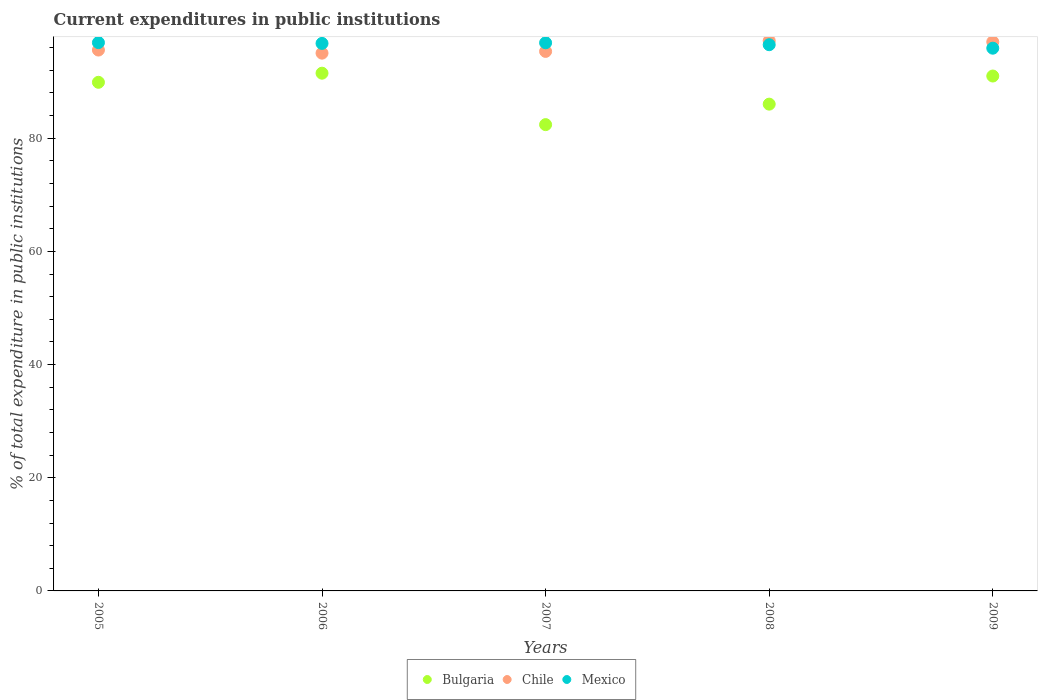What is the current expenditures in public institutions in Chile in 2008?
Provide a succinct answer. 97.23. Across all years, what is the maximum current expenditures in public institutions in Bulgaria?
Ensure brevity in your answer.  91.5. Across all years, what is the minimum current expenditures in public institutions in Bulgaria?
Your response must be concise. 82.41. In which year was the current expenditures in public institutions in Chile minimum?
Make the answer very short. 2006. What is the total current expenditures in public institutions in Chile in the graph?
Provide a succinct answer. 480.24. What is the difference between the current expenditures in public institutions in Mexico in 2007 and that in 2008?
Ensure brevity in your answer.  0.34. What is the difference between the current expenditures in public institutions in Mexico in 2005 and the current expenditures in public institutions in Chile in 2007?
Offer a terse response. 1.55. What is the average current expenditures in public institutions in Bulgaria per year?
Make the answer very short. 88.16. In the year 2008, what is the difference between the current expenditures in public institutions in Chile and current expenditures in public institutions in Mexico?
Your answer should be very brief. 0.7. In how many years, is the current expenditures in public institutions in Bulgaria greater than 20 %?
Make the answer very short. 5. What is the ratio of the current expenditures in public institutions in Mexico in 2007 to that in 2008?
Provide a succinct answer. 1. What is the difference between the highest and the second highest current expenditures in public institutions in Bulgaria?
Offer a very short reply. 0.5. What is the difference between the highest and the lowest current expenditures in public institutions in Mexico?
Provide a short and direct response. 0.99. In how many years, is the current expenditures in public institutions in Bulgaria greater than the average current expenditures in public institutions in Bulgaria taken over all years?
Give a very brief answer. 3. Is it the case that in every year, the sum of the current expenditures in public institutions in Chile and current expenditures in public institutions in Bulgaria  is greater than the current expenditures in public institutions in Mexico?
Give a very brief answer. Yes. Is the current expenditures in public institutions in Bulgaria strictly less than the current expenditures in public institutions in Mexico over the years?
Provide a short and direct response. Yes. What is the difference between two consecutive major ticks on the Y-axis?
Make the answer very short. 20. Does the graph contain any zero values?
Ensure brevity in your answer.  No. Where does the legend appear in the graph?
Your answer should be compact. Bottom center. How many legend labels are there?
Make the answer very short. 3. What is the title of the graph?
Make the answer very short. Current expenditures in public institutions. What is the label or title of the X-axis?
Give a very brief answer. Years. What is the label or title of the Y-axis?
Offer a very short reply. % of total expenditure in public institutions. What is the % of total expenditure in public institutions of Bulgaria in 2005?
Provide a short and direct response. 89.89. What is the % of total expenditure in public institutions in Chile in 2005?
Your response must be concise. 95.59. What is the % of total expenditure in public institutions in Mexico in 2005?
Make the answer very short. 96.9. What is the % of total expenditure in public institutions in Bulgaria in 2006?
Make the answer very short. 91.5. What is the % of total expenditure in public institutions in Chile in 2006?
Ensure brevity in your answer.  95.04. What is the % of total expenditure in public institutions of Mexico in 2006?
Provide a succinct answer. 96.76. What is the % of total expenditure in public institutions of Bulgaria in 2007?
Your response must be concise. 82.41. What is the % of total expenditure in public institutions of Chile in 2007?
Give a very brief answer. 95.35. What is the % of total expenditure in public institutions of Mexico in 2007?
Your response must be concise. 96.87. What is the % of total expenditure in public institutions of Bulgaria in 2008?
Offer a very short reply. 86.03. What is the % of total expenditure in public institutions of Chile in 2008?
Make the answer very short. 97.23. What is the % of total expenditure in public institutions of Mexico in 2008?
Offer a very short reply. 96.53. What is the % of total expenditure in public institutions of Bulgaria in 2009?
Make the answer very short. 91. What is the % of total expenditure in public institutions of Chile in 2009?
Offer a very short reply. 97.03. What is the % of total expenditure in public institutions in Mexico in 2009?
Make the answer very short. 95.92. Across all years, what is the maximum % of total expenditure in public institutions in Bulgaria?
Your response must be concise. 91.5. Across all years, what is the maximum % of total expenditure in public institutions of Chile?
Offer a very short reply. 97.23. Across all years, what is the maximum % of total expenditure in public institutions of Mexico?
Give a very brief answer. 96.9. Across all years, what is the minimum % of total expenditure in public institutions of Bulgaria?
Your response must be concise. 82.41. Across all years, what is the minimum % of total expenditure in public institutions in Chile?
Offer a terse response. 95.04. Across all years, what is the minimum % of total expenditure in public institutions in Mexico?
Give a very brief answer. 95.92. What is the total % of total expenditure in public institutions in Bulgaria in the graph?
Give a very brief answer. 440.82. What is the total % of total expenditure in public institutions in Chile in the graph?
Give a very brief answer. 480.24. What is the total % of total expenditure in public institutions in Mexico in the graph?
Your answer should be compact. 482.98. What is the difference between the % of total expenditure in public institutions of Bulgaria in 2005 and that in 2006?
Keep it short and to the point. -1.61. What is the difference between the % of total expenditure in public institutions of Chile in 2005 and that in 2006?
Offer a very short reply. 0.55. What is the difference between the % of total expenditure in public institutions in Mexico in 2005 and that in 2006?
Provide a short and direct response. 0.14. What is the difference between the % of total expenditure in public institutions in Bulgaria in 2005 and that in 2007?
Give a very brief answer. 7.48. What is the difference between the % of total expenditure in public institutions in Chile in 2005 and that in 2007?
Provide a short and direct response. 0.24. What is the difference between the % of total expenditure in public institutions of Mexico in 2005 and that in 2007?
Your answer should be very brief. 0.03. What is the difference between the % of total expenditure in public institutions in Bulgaria in 2005 and that in 2008?
Provide a succinct answer. 3.86. What is the difference between the % of total expenditure in public institutions in Chile in 2005 and that in 2008?
Provide a short and direct response. -1.64. What is the difference between the % of total expenditure in public institutions of Mexico in 2005 and that in 2008?
Offer a very short reply. 0.37. What is the difference between the % of total expenditure in public institutions of Bulgaria in 2005 and that in 2009?
Give a very brief answer. -1.11. What is the difference between the % of total expenditure in public institutions of Chile in 2005 and that in 2009?
Offer a very short reply. -1.44. What is the difference between the % of total expenditure in public institutions of Mexico in 2005 and that in 2009?
Make the answer very short. 0.99. What is the difference between the % of total expenditure in public institutions of Bulgaria in 2006 and that in 2007?
Offer a terse response. 9.09. What is the difference between the % of total expenditure in public institutions in Chile in 2006 and that in 2007?
Your answer should be very brief. -0.31. What is the difference between the % of total expenditure in public institutions of Mexico in 2006 and that in 2007?
Offer a very short reply. -0.11. What is the difference between the % of total expenditure in public institutions of Bulgaria in 2006 and that in 2008?
Your answer should be very brief. 5.47. What is the difference between the % of total expenditure in public institutions of Chile in 2006 and that in 2008?
Keep it short and to the point. -2.19. What is the difference between the % of total expenditure in public institutions of Mexico in 2006 and that in 2008?
Ensure brevity in your answer.  0.23. What is the difference between the % of total expenditure in public institutions of Bulgaria in 2006 and that in 2009?
Offer a terse response. 0.5. What is the difference between the % of total expenditure in public institutions of Chile in 2006 and that in 2009?
Provide a succinct answer. -1.99. What is the difference between the % of total expenditure in public institutions of Mexico in 2006 and that in 2009?
Your answer should be very brief. 0.84. What is the difference between the % of total expenditure in public institutions in Bulgaria in 2007 and that in 2008?
Offer a very short reply. -3.62. What is the difference between the % of total expenditure in public institutions in Chile in 2007 and that in 2008?
Give a very brief answer. -1.88. What is the difference between the % of total expenditure in public institutions in Mexico in 2007 and that in 2008?
Your response must be concise. 0.34. What is the difference between the % of total expenditure in public institutions of Bulgaria in 2007 and that in 2009?
Keep it short and to the point. -8.59. What is the difference between the % of total expenditure in public institutions of Chile in 2007 and that in 2009?
Keep it short and to the point. -1.68. What is the difference between the % of total expenditure in public institutions in Mexico in 2007 and that in 2009?
Your answer should be compact. 0.95. What is the difference between the % of total expenditure in public institutions in Bulgaria in 2008 and that in 2009?
Provide a succinct answer. -4.97. What is the difference between the % of total expenditure in public institutions in Chile in 2008 and that in 2009?
Your response must be concise. 0.2. What is the difference between the % of total expenditure in public institutions of Mexico in 2008 and that in 2009?
Give a very brief answer. 0.61. What is the difference between the % of total expenditure in public institutions of Bulgaria in 2005 and the % of total expenditure in public institutions of Chile in 2006?
Keep it short and to the point. -5.15. What is the difference between the % of total expenditure in public institutions of Bulgaria in 2005 and the % of total expenditure in public institutions of Mexico in 2006?
Provide a succinct answer. -6.87. What is the difference between the % of total expenditure in public institutions in Chile in 2005 and the % of total expenditure in public institutions in Mexico in 2006?
Your answer should be compact. -1.17. What is the difference between the % of total expenditure in public institutions of Bulgaria in 2005 and the % of total expenditure in public institutions of Chile in 2007?
Your response must be concise. -5.46. What is the difference between the % of total expenditure in public institutions in Bulgaria in 2005 and the % of total expenditure in public institutions in Mexico in 2007?
Provide a short and direct response. -6.98. What is the difference between the % of total expenditure in public institutions of Chile in 2005 and the % of total expenditure in public institutions of Mexico in 2007?
Give a very brief answer. -1.28. What is the difference between the % of total expenditure in public institutions of Bulgaria in 2005 and the % of total expenditure in public institutions of Chile in 2008?
Ensure brevity in your answer.  -7.34. What is the difference between the % of total expenditure in public institutions in Bulgaria in 2005 and the % of total expenditure in public institutions in Mexico in 2008?
Your answer should be very brief. -6.64. What is the difference between the % of total expenditure in public institutions in Chile in 2005 and the % of total expenditure in public institutions in Mexico in 2008?
Your answer should be compact. -0.94. What is the difference between the % of total expenditure in public institutions in Bulgaria in 2005 and the % of total expenditure in public institutions in Chile in 2009?
Give a very brief answer. -7.14. What is the difference between the % of total expenditure in public institutions in Bulgaria in 2005 and the % of total expenditure in public institutions in Mexico in 2009?
Give a very brief answer. -6.03. What is the difference between the % of total expenditure in public institutions in Chile in 2005 and the % of total expenditure in public institutions in Mexico in 2009?
Provide a short and direct response. -0.33. What is the difference between the % of total expenditure in public institutions in Bulgaria in 2006 and the % of total expenditure in public institutions in Chile in 2007?
Make the answer very short. -3.85. What is the difference between the % of total expenditure in public institutions of Bulgaria in 2006 and the % of total expenditure in public institutions of Mexico in 2007?
Ensure brevity in your answer.  -5.37. What is the difference between the % of total expenditure in public institutions of Chile in 2006 and the % of total expenditure in public institutions of Mexico in 2007?
Your answer should be very brief. -1.83. What is the difference between the % of total expenditure in public institutions in Bulgaria in 2006 and the % of total expenditure in public institutions in Chile in 2008?
Offer a very short reply. -5.73. What is the difference between the % of total expenditure in public institutions of Bulgaria in 2006 and the % of total expenditure in public institutions of Mexico in 2008?
Your response must be concise. -5.03. What is the difference between the % of total expenditure in public institutions of Chile in 2006 and the % of total expenditure in public institutions of Mexico in 2008?
Offer a terse response. -1.49. What is the difference between the % of total expenditure in public institutions in Bulgaria in 2006 and the % of total expenditure in public institutions in Chile in 2009?
Give a very brief answer. -5.53. What is the difference between the % of total expenditure in public institutions in Bulgaria in 2006 and the % of total expenditure in public institutions in Mexico in 2009?
Your answer should be compact. -4.42. What is the difference between the % of total expenditure in public institutions of Chile in 2006 and the % of total expenditure in public institutions of Mexico in 2009?
Keep it short and to the point. -0.88. What is the difference between the % of total expenditure in public institutions in Bulgaria in 2007 and the % of total expenditure in public institutions in Chile in 2008?
Provide a succinct answer. -14.82. What is the difference between the % of total expenditure in public institutions in Bulgaria in 2007 and the % of total expenditure in public institutions in Mexico in 2008?
Provide a succinct answer. -14.12. What is the difference between the % of total expenditure in public institutions in Chile in 2007 and the % of total expenditure in public institutions in Mexico in 2008?
Offer a terse response. -1.18. What is the difference between the % of total expenditure in public institutions in Bulgaria in 2007 and the % of total expenditure in public institutions in Chile in 2009?
Make the answer very short. -14.62. What is the difference between the % of total expenditure in public institutions of Bulgaria in 2007 and the % of total expenditure in public institutions of Mexico in 2009?
Your response must be concise. -13.51. What is the difference between the % of total expenditure in public institutions in Chile in 2007 and the % of total expenditure in public institutions in Mexico in 2009?
Give a very brief answer. -0.57. What is the difference between the % of total expenditure in public institutions in Bulgaria in 2008 and the % of total expenditure in public institutions in Chile in 2009?
Your answer should be very brief. -11. What is the difference between the % of total expenditure in public institutions in Bulgaria in 2008 and the % of total expenditure in public institutions in Mexico in 2009?
Make the answer very short. -9.89. What is the difference between the % of total expenditure in public institutions of Chile in 2008 and the % of total expenditure in public institutions of Mexico in 2009?
Offer a terse response. 1.31. What is the average % of total expenditure in public institutions in Bulgaria per year?
Provide a short and direct response. 88.16. What is the average % of total expenditure in public institutions of Chile per year?
Your answer should be compact. 96.05. What is the average % of total expenditure in public institutions in Mexico per year?
Your response must be concise. 96.6. In the year 2005, what is the difference between the % of total expenditure in public institutions in Bulgaria and % of total expenditure in public institutions in Chile?
Provide a short and direct response. -5.7. In the year 2005, what is the difference between the % of total expenditure in public institutions of Bulgaria and % of total expenditure in public institutions of Mexico?
Your response must be concise. -7.01. In the year 2005, what is the difference between the % of total expenditure in public institutions in Chile and % of total expenditure in public institutions in Mexico?
Make the answer very short. -1.31. In the year 2006, what is the difference between the % of total expenditure in public institutions in Bulgaria and % of total expenditure in public institutions in Chile?
Provide a short and direct response. -3.54. In the year 2006, what is the difference between the % of total expenditure in public institutions of Bulgaria and % of total expenditure in public institutions of Mexico?
Your answer should be very brief. -5.26. In the year 2006, what is the difference between the % of total expenditure in public institutions of Chile and % of total expenditure in public institutions of Mexico?
Give a very brief answer. -1.72. In the year 2007, what is the difference between the % of total expenditure in public institutions in Bulgaria and % of total expenditure in public institutions in Chile?
Keep it short and to the point. -12.94. In the year 2007, what is the difference between the % of total expenditure in public institutions in Bulgaria and % of total expenditure in public institutions in Mexico?
Offer a terse response. -14.46. In the year 2007, what is the difference between the % of total expenditure in public institutions in Chile and % of total expenditure in public institutions in Mexico?
Your answer should be very brief. -1.52. In the year 2008, what is the difference between the % of total expenditure in public institutions in Bulgaria and % of total expenditure in public institutions in Chile?
Your response must be concise. -11.2. In the year 2008, what is the difference between the % of total expenditure in public institutions of Bulgaria and % of total expenditure in public institutions of Mexico?
Your answer should be compact. -10.5. In the year 2008, what is the difference between the % of total expenditure in public institutions in Chile and % of total expenditure in public institutions in Mexico?
Offer a terse response. 0.7. In the year 2009, what is the difference between the % of total expenditure in public institutions in Bulgaria and % of total expenditure in public institutions in Chile?
Keep it short and to the point. -6.03. In the year 2009, what is the difference between the % of total expenditure in public institutions of Bulgaria and % of total expenditure in public institutions of Mexico?
Offer a very short reply. -4.92. In the year 2009, what is the difference between the % of total expenditure in public institutions in Chile and % of total expenditure in public institutions in Mexico?
Ensure brevity in your answer.  1.11. What is the ratio of the % of total expenditure in public institutions of Bulgaria in 2005 to that in 2006?
Provide a succinct answer. 0.98. What is the ratio of the % of total expenditure in public institutions of Mexico in 2005 to that in 2006?
Make the answer very short. 1. What is the ratio of the % of total expenditure in public institutions of Bulgaria in 2005 to that in 2007?
Your answer should be compact. 1.09. What is the ratio of the % of total expenditure in public institutions of Chile in 2005 to that in 2007?
Ensure brevity in your answer.  1. What is the ratio of the % of total expenditure in public institutions of Bulgaria in 2005 to that in 2008?
Make the answer very short. 1.04. What is the ratio of the % of total expenditure in public institutions in Chile in 2005 to that in 2008?
Your answer should be very brief. 0.98. What is the ratio of the % of total expenditure in public institutions of Mexico in 2005 to that in 2008?
Keep it short and to the point. 1. What is the ratio of the % of total expenditure in public institutions in Bulgaria in 2005 to that in 2009?
Your answer should be very brief. 0.99. What is the ratio of the % of total expenditure in public institutions of Chile in 2005 to that in 2009?
Make the answer very short. 0.99. What is the ratio of the % of total expenditure in public institutions in Mexico in 2005 to that in 2009?
Your answer should be compact. 1.01. What is the ratio of the % of total expenditure in public institutions in Bulgaria in 2006 to that in 2007?
Make the answer very short. 1.11. What is the ratio of the % of total expenditure in public institutions in Chile in 2006 to that in 2007?
Ensure brevity in your answer.  1. What is the ratio of the % of total expenditure in public institutions in Mexico in 2006 to that in 2007?
Provide a succinct answer. 1. What is the ratio of the % of total expenditure in public institutions in Bulgaria in 2006 to that in 2008?
Your answer should be compact. 1.06. What is the ratio of the % of total expenditure in public institutions of Chile in 2006 to that in 2008?
Your answer should be very brief. 0.98. What is the ratio of the % of total expenditure in public institutions in Chile in 2006 to that in 2009?
Provide a short and direct response. 0.98. What is the ratio of the % of total expenditure in public institutions in Mexico in 2006 to that in 2009?
Offer a very short reply. 1.01. What is the ratio of the % of total expenditure in public institutions in Bulgaria in 2007 to that in 2008?
Offer a terse response. 0.96. What is the ratio of the % of total expenditure in public institutions of Chile in 2007 to that in 2008?
Offer a very short reply. 0.98. What is the ratio of the % of total expenditure in public institutions in Bulgaria in 2007 to that in 2009?
Offer a terse response. 0.91. What is the ratio of the % of total expenditure in public institutions of Chile in 2007 to that in 2009?
Your answer should be very brief. 0.98. What is the ratio of the % of total expenditure in public institutions of Mexico in 2007 to that in 2009?
Give a very brief answer. 1.01. What is the ratio of the % of total expenditure in public institutions in Bulgaria in 2008 to that in 2009?
Make the answer very short. 0.95. What is the ratio of the % of total expenditure in public institutions in Chile in 2008 to that in 2009?
Ensure brevity in your answer.  1. What is the ratio of the % of total expenditure in public institutions of Mexico in 2008 to that in 2009?
Provide a short and direct response. 1.01. What is the difference between the highest and the second highest % of total expenditure in public institutions in Bulgaria?
Make the answer very short. 0.5. What is the difference between the highest and the second highest % of total expenditure in public institutions in Chile?
Your response must be concise. 0.2. What is the difference between the highest and the second highest % of total expenditure in public institutions in Mexico?
Provide a succinct answer. 0.03. What is the difference between the highest and the lowest % of total expenditure in public institutions of Bulgaria?
Your response must be concise. 9.09. What is the difference between the highest and the lowest % of total expenditure in public institutions in Chile?
Provide a short and direct response. 2.19. What is the difference between the highest and the lowest % of total expenditure in public institutions of Mexico?
Your response must be concise. 0.99. 